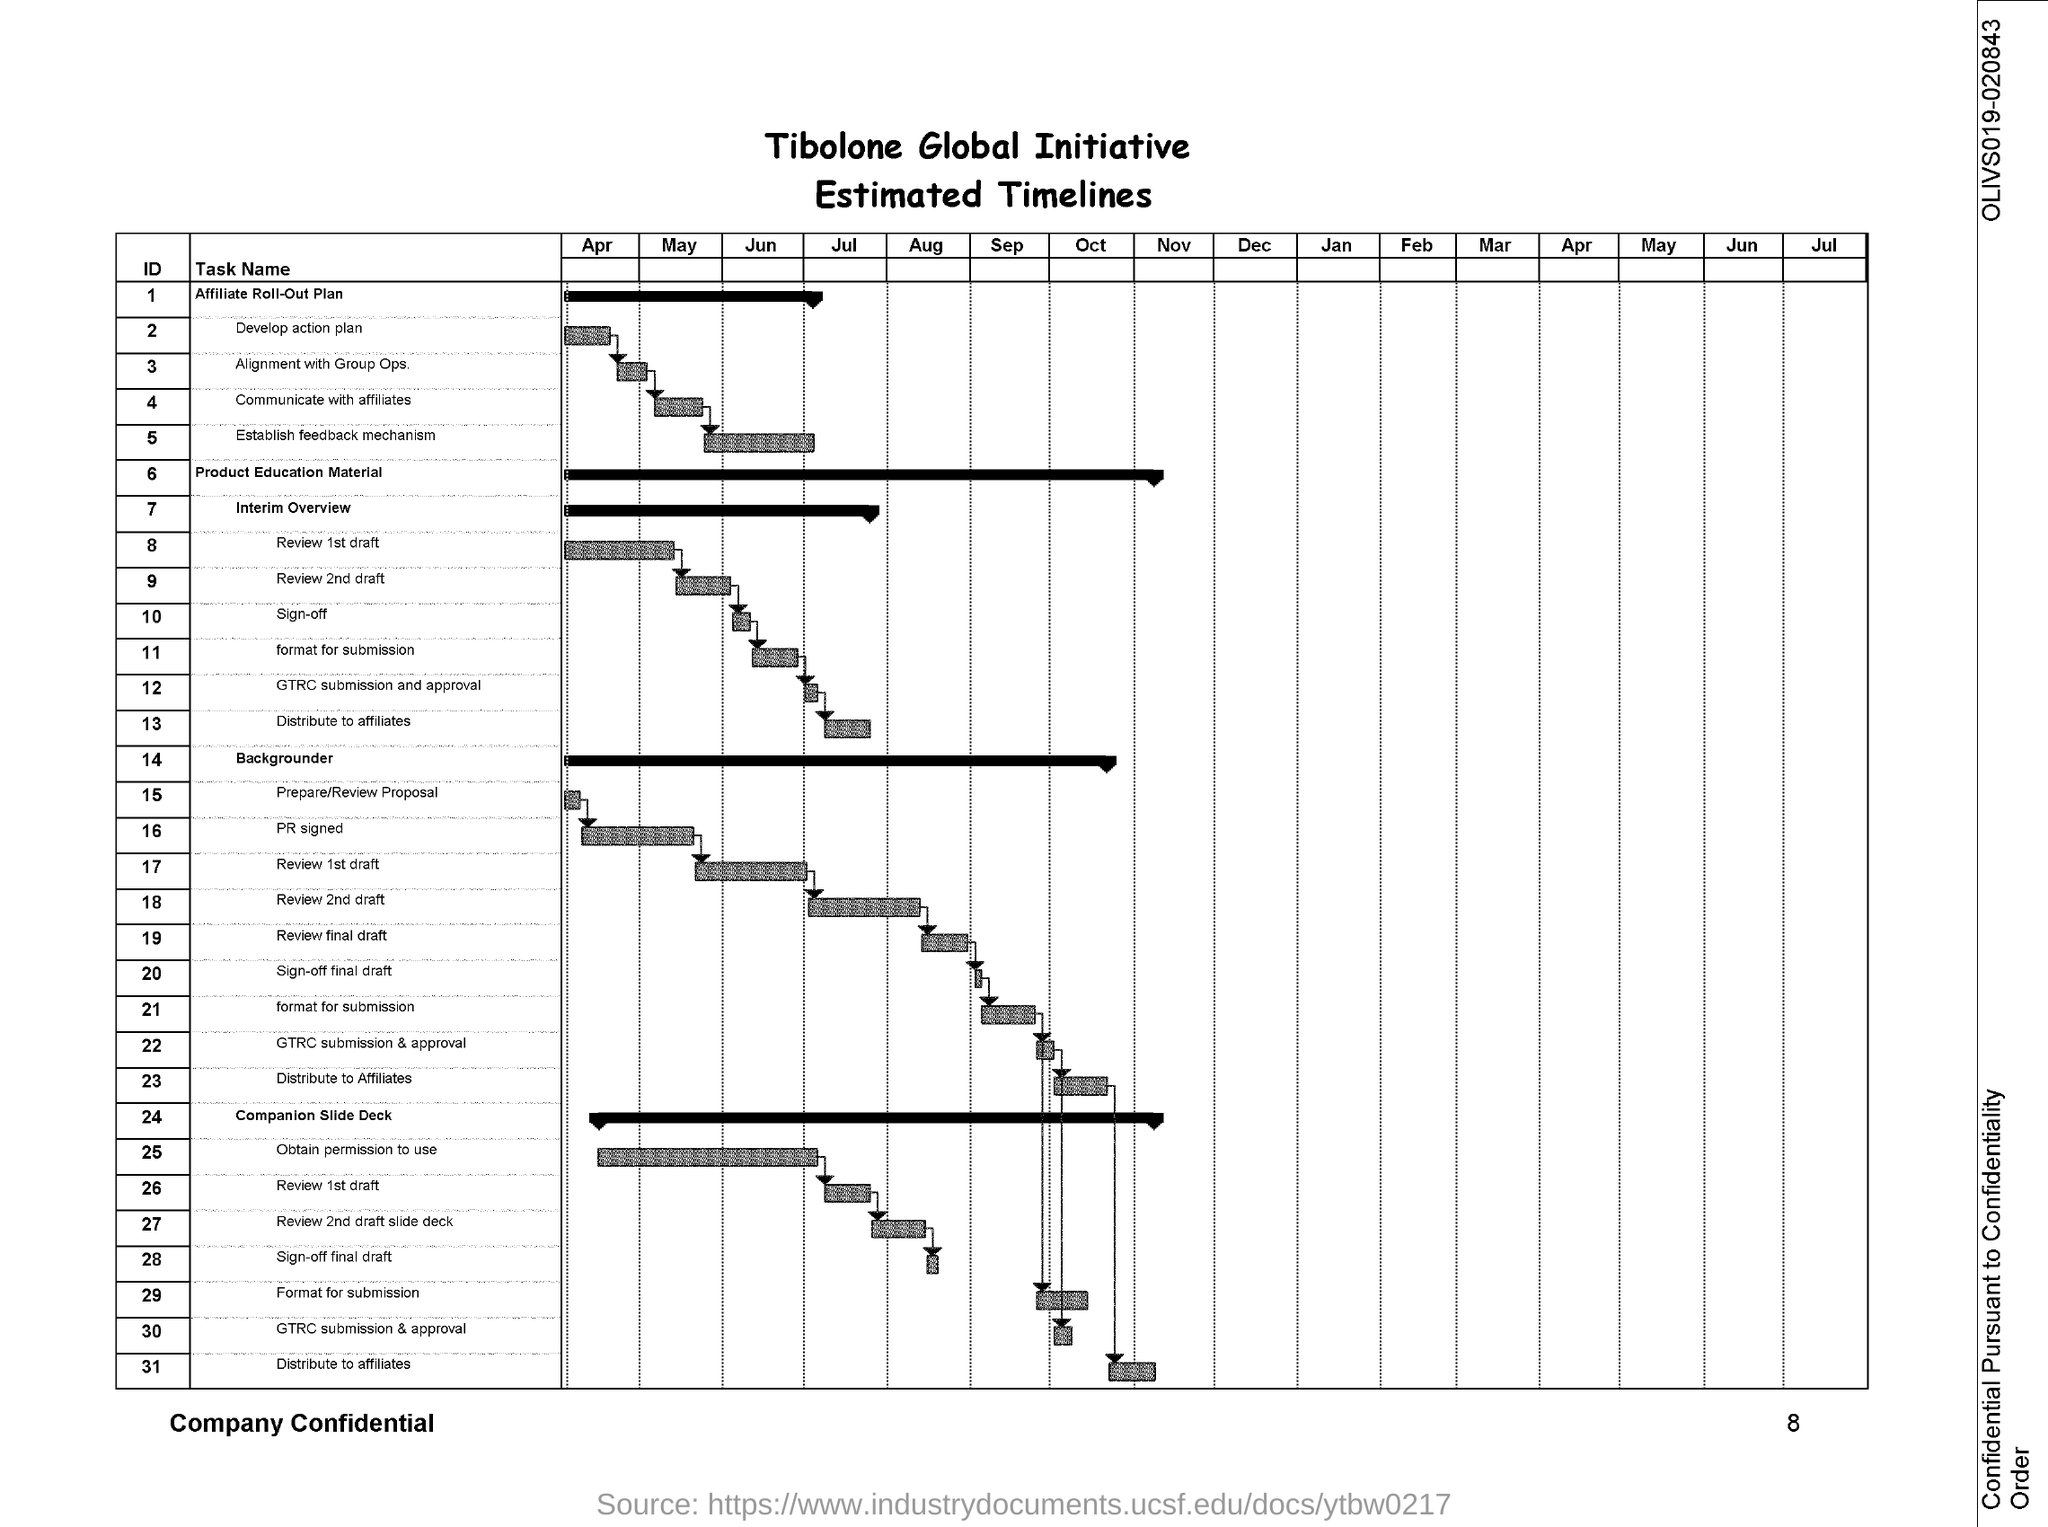What is the Document Number?
Give a very brief answer. OLIVS019-020843. What is the Page Number?
Give a very brief answer. 8. 